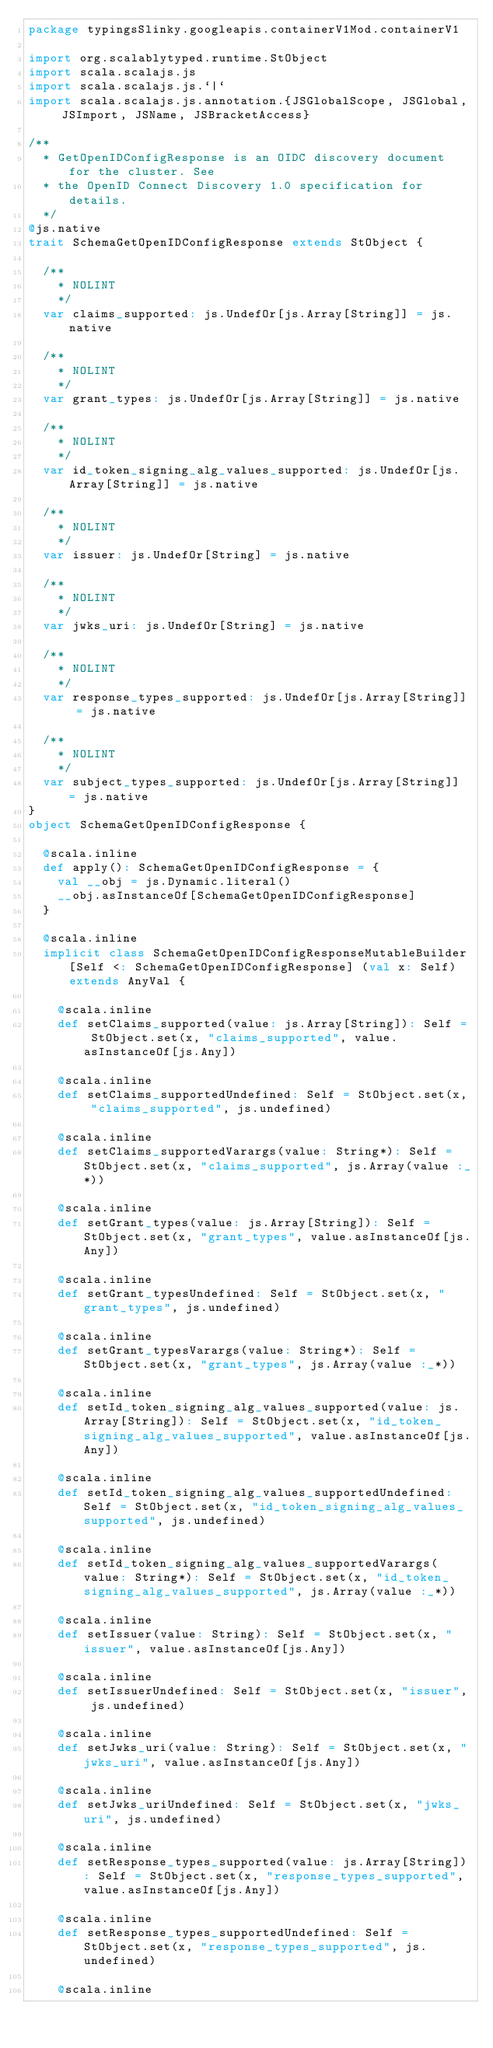<code> <loc_0><loc_0><loc_500><loc_500><_Scala_>package typingsSlinky.googleapis.containerV1Mod.containerV1

import org.scalablytyped.runtime.StObject
import scala.scalajs.js
import scala.scalajs.js.`|`
import scala.scalajs.js.annotation.{JSGlobalScope, JSGlobal, JSImport, JSName, JSBracketAccess}

/**
  * GetOpenIDConfigResponse is an OIDC discovery document for the cluster. See
  * the OpenID Connect Discovery 1.0 specification for details.
  */
@js.native
trait SchemaGetOpenIDConfigResponse extends StObject {
  
  /**
    * NOLINT
    */
  var claims_supported: js.UndefOr[js.Array[String]] = js.native
  
  /**
    * NOLINT
    */
  var grant_types: js.UndefOr[js.Array[String]] = js.native
  
  /**
    * NOLINT
    */
  var id_token_signing_alg_values_supported: js.UndefOr[js.Array[String]] = js.native
  
  /**
    * NOLINT
    */
  var issuer: js.UndefOr[String] = js.native
  
  /**
    * NOLINT
    */
  var jwks_uri: js.UndefOr[String] = js.native
  
  /**
    * NOLINT
    */
  var response_types_supported: js.UndefOr[js.Array[String]] = js.native
  
  /**
    * NOLINT
    */
  var subject_types_supported: js.UndefOr[js.Array[String]] = js.native
}
object SchemaGetOpenIDConfigResponse {
  
  @scala.inline
  def apply(): SchemaGetOpenIDConfigResponse = {
    val __obj = js.Dynamic.literal()
    __obj.asInstanceOf[SchemaGetOpenIDConfigResponse]
  }
  
  @scala.inline
  implicit class SchemaGetOpenIDConfigResponseMutableBuilder[Self <: SchemaGetOpenIDConfigResponse] (val x: Self) extends AnyVal {
    
    @scala.inline
    def setClaims_supported(value: js.Array[String]): Self = StObject.set(x, "claims_supported", value.asInstanceOf[js.Any])
    
    @scala.inline
    def setClaims_supportedUndefined: Self = StObject.set(x, "claims_supported", js.undefined)
    
    @scala.inline
    def setClaims_supportedVarargs(value: String*): Self = StObject.set(x, "claims_supported", js.Array(value :_*))
    
    @scala.inline
    def setGrant_types(value: js.Array[String]): Self = StObject.set(x, "grant_types", value.asInstanceOf[js.Any])
    
    @scala.inline
    def setGrant_typesUndefined: Self = StObject.set(x, "grant_types", js.undefined)
    
    @scala.inline
    def setGrant_typesVarargs(value: String*): Self = StObject.set(x, "grant_types", js.Array(value :_*))
    
    @scala.inline
    def setId_token_signing_alg_values_supported(value: js.Array[String]): Self = StObject.set(x, "id_token_signing_alg_values_supported", value.asInstanceOf[js.Any])
    
    @scala.inline
    def setId_token_signing_alg_values_supportedUndefined: Self = StObject.set(x, "id_token_signing_alg_values_supported", js.undefined)
    
    @scala.inline
    def setId_token_signing_alg_values_supportedVarargs(value: String*): Self = StObject.set(x, "id_token_signing_alg_values_supported", js.Array(value :_*))
    
    @scala.inline
    def setIssuer(value: String): Self = StObject.set(x, "issuer", value.asInstanceOf[js.Any])
    
    @scala.inline
    def setIssuerUndefined: Self = StObject.set(x, "issuer", js.undefined)
    
    @scala.inline
    def setJwks_uri(value: String): Self = StObject.set(x, "jwks_uri", value.asInstanceOf[js.Any])
    
    @scala.inline
    def setJwks_uriUndefined: Self = StObject.set(x, "jwks_uri", js.undefined)
    
    @scala.inline
    def setResponse_types_supported(value: js.Array[String]): Self = StObject.set(x, "response_types_supported", value.asInstanceOf[js.Any])
    
    @scala.inline
    def setResponse_types_supportedUndefined: Self = StObject.set(x, "response_types_supported", js.undefined)
    
    @scala.inline</code> 